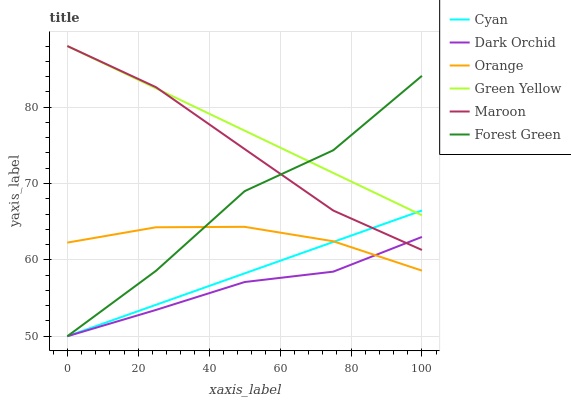Does Dark Orchid have the minimum area under the curve?
Answer yes or no. Yes. Does Green Yellow have the maximum area under the curve?
Answer yes or no. Yes. Does Forest Green have the minimum area under the curve?
Answer yes or no. No. Does Forest Green have the maximum area under the curve?
Answer yes or no. No. Is Cyan the smoothest?
Answer yes or no. Yes. Is Forest Green the roughest?
Answer yes or no. Yes. Is Dark Orchid the smoothest?
Answer yes or no. No. Is Dark Orchid the roughest?
Answer yes or no. No. Does Forest Green have the lowest value?
Answer yes or no. Yes. Does Orange have the lowest value?
Answer yes or no. No. Does Green Yellow have the highest value?
Answer yes or no. Yes. Does Forest Green have the highest value?
Answer yes or no. No. Is Orange less than Green Yellow?
Answer yes or no. Yes. Is Maroon greater than Orange?
Answer yes or no. Yes. Does Dark Orchid intersect Forest Green?
Answer yes or no. Yes. Is Dark Orchid less than Forest Green?
Answer yes or no. No. Is Dark Orchid greater than Forest Green?
Answer yes or no. No. Does Orange intersect Green Yellow?
Answer yes or no. No. 